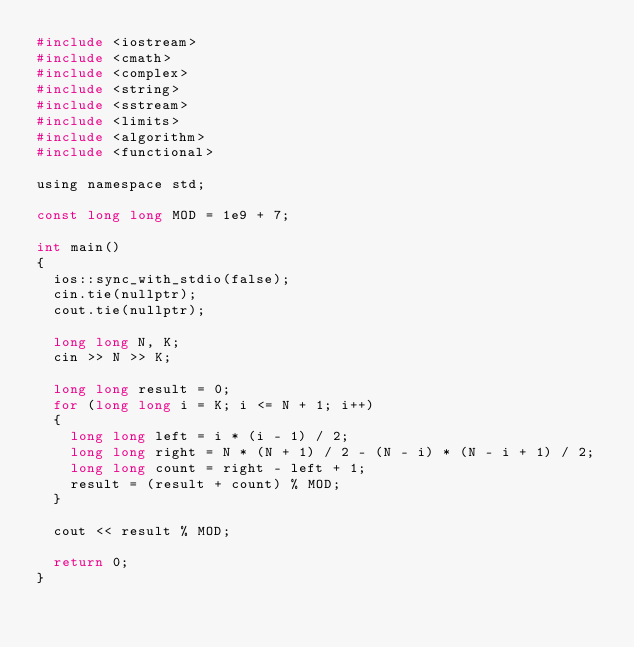Convert code to text. <code><loc_0><loc_0><loc_500><loc_500><_C_>#include <iostream>
#include <cmath>
#include <complex>
#include <string>
#include <sstream>
#include <limits>
#include <algorithm>
#include <functional>

using namespace std;

const long long MOD = 1e9 + 7;

int main()
{
	ios::sync_with_stdio(false);
	cin.tie(nullptr);
	cout.tie(nullptr);

	long long N, K;
	cin >> N >> K;

	long long result = 0;
	for (long long i = K; i <= N + 1; i++)
	{
		long long left = i * (i - 1) / 2;
		long long right = N * (N + 1) / 2 - (N - i) * (N - i + 1) / 2;
		long long count = right - left + 1;
		result = (result + count) % MOD;
	}

	cout << result % MOD;

	return 0;
}
</code> 